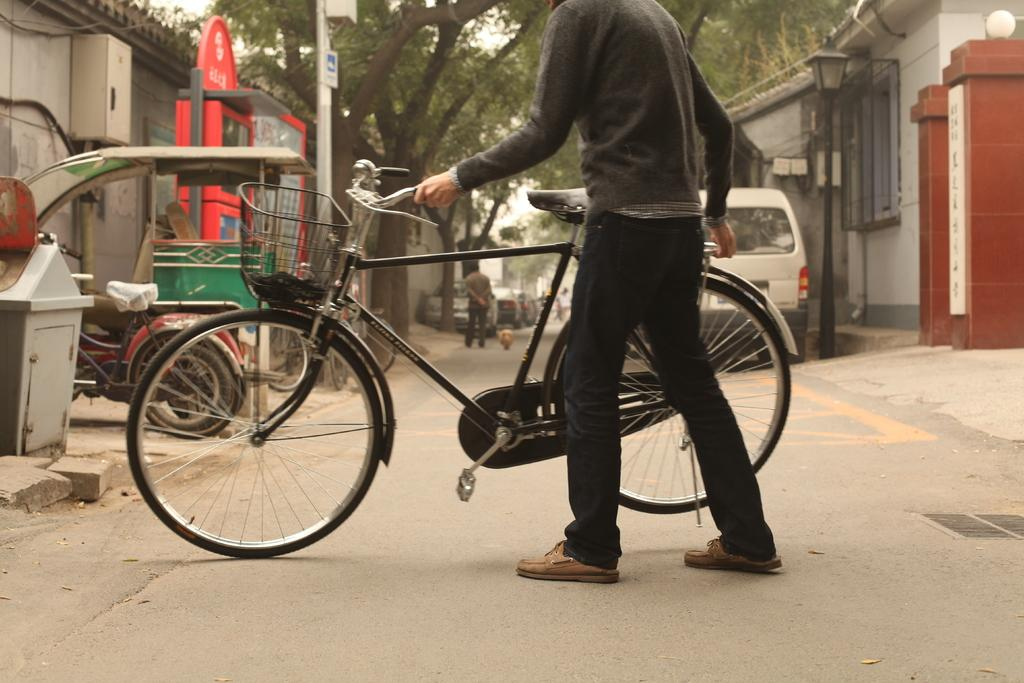What is the person in the image holding? The person in the image is holding a bicycle. Are there any other people in the image? Yes, there are other people in the image. What else can be seen in the image besides people? There are vehicles and buildings visible in the image. What type of natural elements can be seen in the image? There are trees on either side of the image. What type of home is visible in the image? There is no home present in the image. What kind of vessel is being used by the people in the image? There is no vessel present in the image; the people are on foot or riding bicycles. 